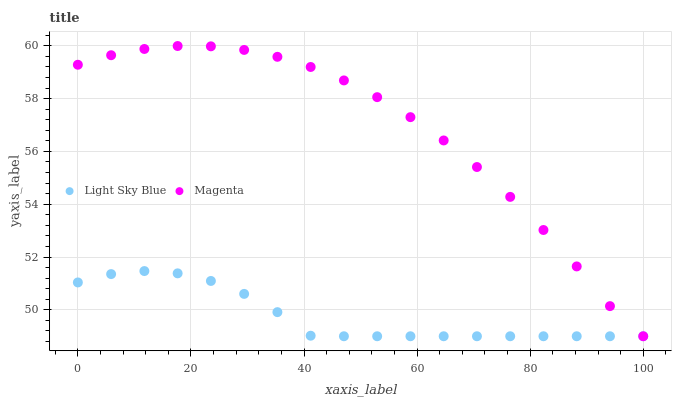Does Light Sky Blue have the minimum area under the curve?
Answer yes or no. Yes. Does Magenta have the maximum area under the curve?
Answer yes or no. Yes. Does Light Sky Blue have the maximum area under the curve?
Answer yes or no. No. Is Light Sky Blue the smoothest?
Answer yes or no. Yes. Is Magenta the roughest?
Answer yes or no. Yes. Is Light Sky Blue the roughest?
Answer yes or no. No. Does Magenta have the lowest value?
Answer yes or no. Yes. Does Magenta have the highest value?
Answer yes or no. Yes. Does Light Sky Blue have the highest value?
Answer yes or no. No. Does Light Sky Blue intersect Magenta?
Answer yes or no. Yes. Is Light Sky Blue less than Magenta?
Answer yes or no. No. Is Light Sky Blue greater than Magenta?
Answer yes or no. No. 